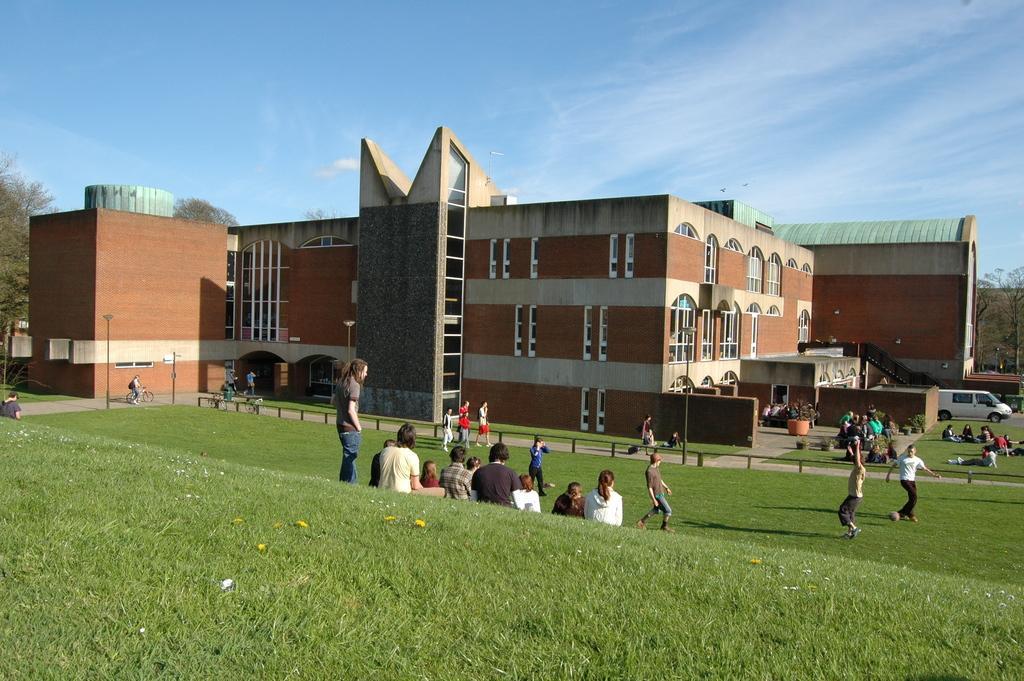In one or two sentences, can you explain what this image depicts? In this image there are buildings and trees. We can see poles. At the bottom there is grass and we can see people. On the right there is a car. In the background there is sky. 